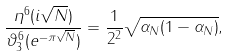<formula> <loc_0><loc_0><loc_500><loc_500>\frac { \eta ^ { 6 } ( i \sqrt { N } ) } { \vartheta _ { 3 } ^ { 6 } ( e ^ { - \pi \sqrt { N } } ) } = \frac { 1 } { 2 ^ { 2 } } \sqrt { \alpha _ { N } ( 1 - \alpha _ { N } ) } ,</formula> 